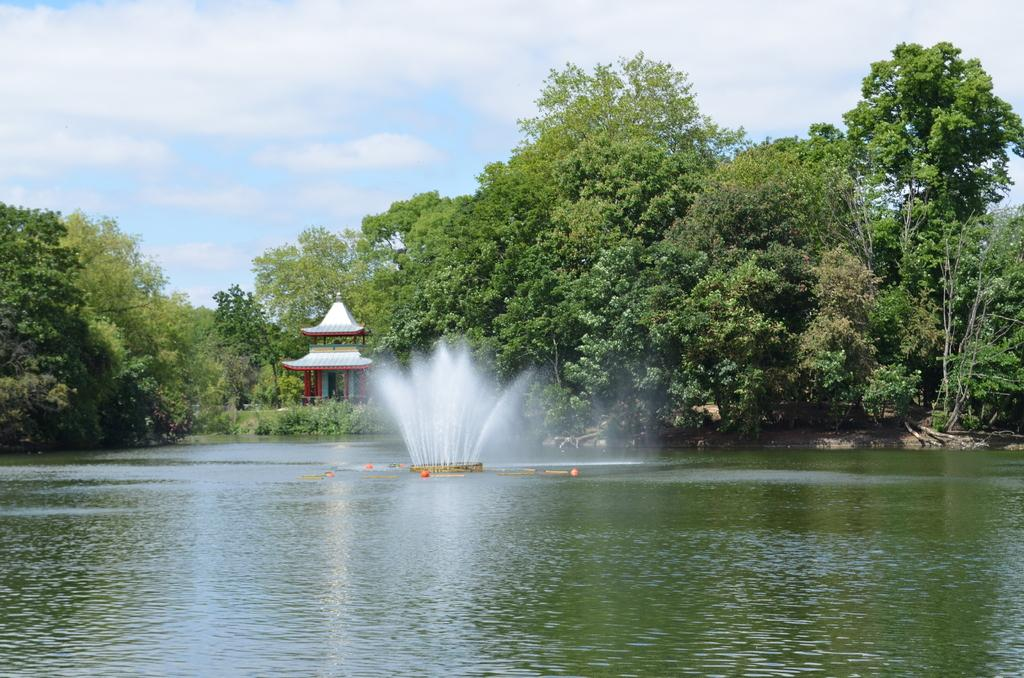What is the main feature in the image? There is a fountain in the image. What other body of water is present in the image? There is a lake in the image. What type of structure can be seen in the image? There is a building in the image. What natural elements are visible in the background of the image? There are trees in the backdrop of the image. Where is the mailbox located in the image? There is no mailbox present in the image. How comfortable is the cushion in the image? There is no cushion present in the image. 